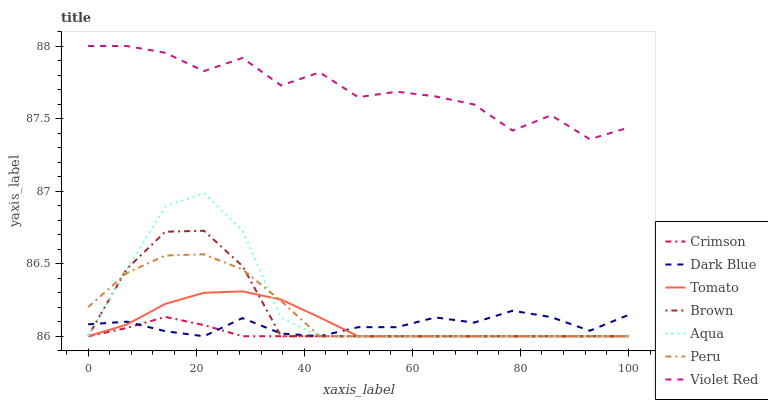Does Crimson have the minimum area under the curve?
Answer yes or no. Yes. Does Violet Red have the maximum area under the curve?
Answer yes or no. Yes. Does Brown have the minimum area under the curve?
Answer yes or no. No. Does Brown have the maximum area under the curve?
Answer yes or no. No. Is Crimson the smoothest?
Answer yes or no. Yes. Is Violet Red the roughest?
Answer yes or no. Yes. Is Brown the smoothest?
Answer yes or no. No. Is Brown the roughest?
Answer yes or no. No. Does Violet Red have the lowest value?
Answer yes or no. No. Does Violet Red have the highest value?
Answer yes or no. Yes. Does Brown have the highest value?
Answer yes or no. No. Is Peru less than Violet Red?
Answer yes or no. Yes. Is Violet Red greater than Dark Blue?
Answer yes or no. Yes. Does Brown intersect Aqua?
Answer yes or no. Yes. Is Brown less than Aqua?
Answer yes or no. No. Is Brown greater than Aqua?
Answer yes or no. No. Does Peru intersect Violet Red?
Answer yes or no. No. 